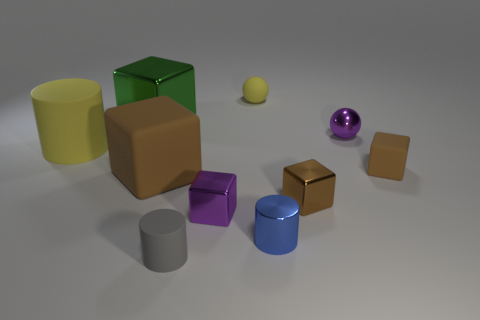Subtract all tiny rubber cubes. How many cubes are left? 4 Subtract all brown cylinders. How many brown cubes are left? 3 Subtract 1 cubes. How many cubes are left? 4 Subtract all green cubes. How many cubes are left? 4 Subtract all cylinders. How many objects are left? 7 Subtract all big brown blocks. Subtract all purple metal spheres. How many objects are left? 8 Add 5 small brown matte things. How many small brown matte things are left? 6 Add 7 blue metal blocks. How many blue metal blocks exist? 7 Subtract 0 blue balls. How many objects are left? 10 Subtract all purple blocks. Subtract all red cylinders. How many blocks are left? 4 